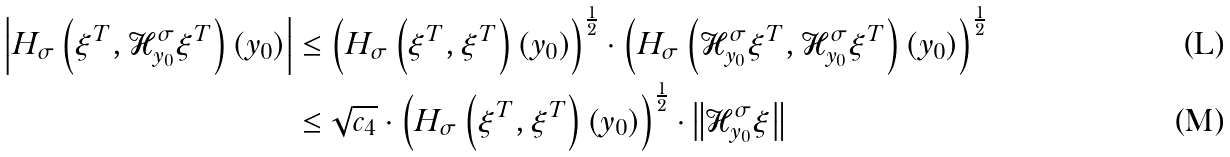<formula> <loc_0><loc_0><loc_500><loc_500>\left | H _ { \sigma } \left ( \xi ^ { T } , \mathcal { H } _ { y _ { 0 } } ^ { \sigma } \xi ^ { T } \right ) ( y _ { 0 } ) \right | & \leq \left ( H _ { \sigma } \left ( \xi ^ { T } , \xi ^ { T } \right ) ( y _ { 0 } ) \right ) ^ { \frac { 1 } { 2 } } \cdot \left ( H _ { \sigma } \left ( \mathcal { H } _ { y _ { 0 } } ^ { \sigma } \xi ^ { T } , \mathcal { H } _ { y _ { 0 } } ^ { \sigma } \xi ^ { T } \right ) ( y _ { 0 } ) \right ) ^ { \frac { 1 } { 2 } } \\ & \leq \sqrt { c _ { 4 } } \cdot \left ( H _ { \sigma } \left ( \xi ^ { T } , \xi ^ { T } \right ) ( y _ { 0 } ) \right ) ^ { \frac { 1 } { 2 } } \cdot \left \| \mathcal { H } _ { y _ { 0 } } ^ { \sigma } \xi \right \|</formula> 